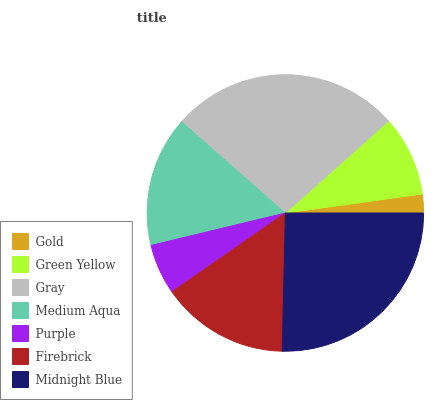Is Gold the minimum?
Answer yes or no. Yes. Is Gray the maximum?
Answer yes or no. Yes. Is Green Yellow the minimum?
Answer yes or no. No. Is Green Yellow the maximum?
Answer yes or no. No. Is Green Yellow greater than Gold?
Answer yes or no. Yes. Is Gold less than Green Yellow?
Answer yes or no. Yes. Is Gold greater than Green Yellow?
Answer yes or no. No. Is Green Yellow less than Gold?
Answer yes or no. No. Is Firebrick the high median?
Answer yes or no. Yes. Is Firebrick the low median?
Answer yes or no. Yes. Is Purple the high median?
Answer yes or no. No. Is Midnight Blue the low median?
Answer yes or no. No. 